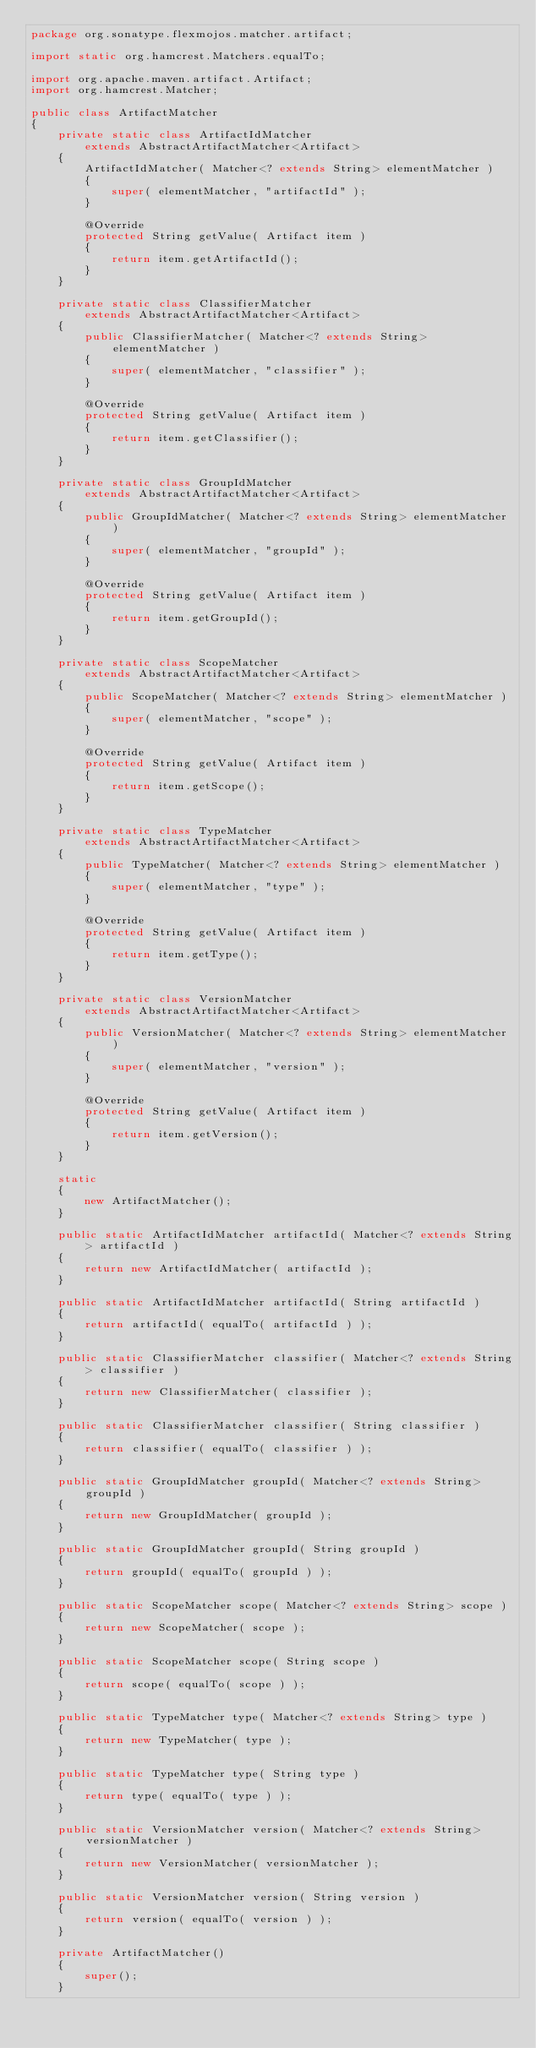<code> <loc_0><loc_0><loc_500><loc_500><_Java_>package org.sonatype.flexmojos.matcher.artifact;

import static org.hamcrest.Matchers.equalTo;

import org.apache.maven.artifact.Artifact;
import org.hamcrest.Matcher;

public class ArtifactMatcher
{
    private static class ArtifactIdMatcher
        extends AbstractArtifactMatcher<Artifact>
    {
        ArtifactIdMatcher( Matcher<? extends String> elementMatcher )
        {
            super( elementMatcher, "artifactId" );
        }

        @Override
        protected String getValue( Artifact item )
        {
            return item.getArtifactId();
        }
    }

    private static class ClassifierMatcher
        extends AbstractArtifactMatcher<Artifact>
    {
        public ClassifierMatcher( Matcher<? extends String> elementMatcher )
        {
            super( elementMatcher, "classifier" );
        }

        @Override
        protected String getValue( Artifact item )
        {
            return item.getClassifier();
        }
    }

    private static class GroupIdMatcher
        extends AbstractArtifactMatcher<Artifact>
    {
        public GroupIdMatcher( Matcher<? extends String> elementMatcher )
        {
            super( elementMatcher, "groupId" );
        }

        @Override
        protected String getValue( Artifact item )
        {
            return item.getGroupId();
        }
    }

    private static class ScopeMatcher
        extends AbstractArtifactMatcher<Artifact>
    {
        public ScopeMatcher( Matcher<? extends String> elementMatcher )
        {
            super( elementMatcher, "scope" );
        }

        @Override
        protected String getValue( Artifact item )
        {
            return item.getScope();
        }
    }

    private static class TypeMatcher
        extends AbstractArtifactMatcher<Artifact>
    {
        public TypeMatcher( Matcher<? extends String> elementMatcher )
        {
            super( elementMatcher, "type" );
        }

        @Override
        protected String getValue( Artifact item )
        {
            return item.getType();
        }
    }

    private static class VersionMatcher
        extends AbstractArtifactMatcher<Artifact>
    {
        public VersionMatcher( Matcher<? extends String> elementMatcher )
        {
            super( elementMatcher, "version" );
        }

        @Override
        protected String getValue( Artifact item )
        {
            return item.getVersion();
        }
    }

    static
    {
        new ArtifactMatcher();
    }

    public static ArtifactIdMatcher artifactId( Matcher<? extends String> artifactId )
    {
        return new ArtifactIdMatcher( artifactId );
    }

    public static ArtifactIdMatcher artifactId( String artifactId )
    {
        return artifactId( equalTo( artifactId ) );
    }

    public static ClassifierMatcher classifier( Matcher<? extends String> classifier )
    {
        return new ClassifierMatcher( classifier );
    }

    public static ClassifierMatcher classifier( String classifier )
    {
        return classifier( equalTo( classifier ) );
    }

    public static GroupIdMatcher groupId( Matcher<? extends String> groupId )
    {
        return new GroupIdMatcher( groupId );
    }

    public static GroupIdMatcher groupId( String groupId )
    {
        return groupId( equalTo( groupId ) );
    }

    public static ScopeMatcher scope( Matcher<? extends String> scope )
    {
        return new ScopeMatcher( scope );
    }

    public static ScopeMatcher scope( String scope )
    {
        return scope( equalTo( scope ) );
    }

    public static TypeMatcher type( Matcher<? extends String> type )
    {
        return new TypeMatcher( type );
    }

    public static TypeMatcher type( String type )
    {
        return type( equalTo( type ) );
    }

    public static VersionMatcher version( Matcher<? extends String> versionMatcher )
    {
        return new VersionMatcher( versionMatcher );
    }

    public static VersionMatcher version( String version )
    {
        return version( equalTo( version ) );
    }

    private ArtifactMatcher()
    {
        super();
    }
</code> 